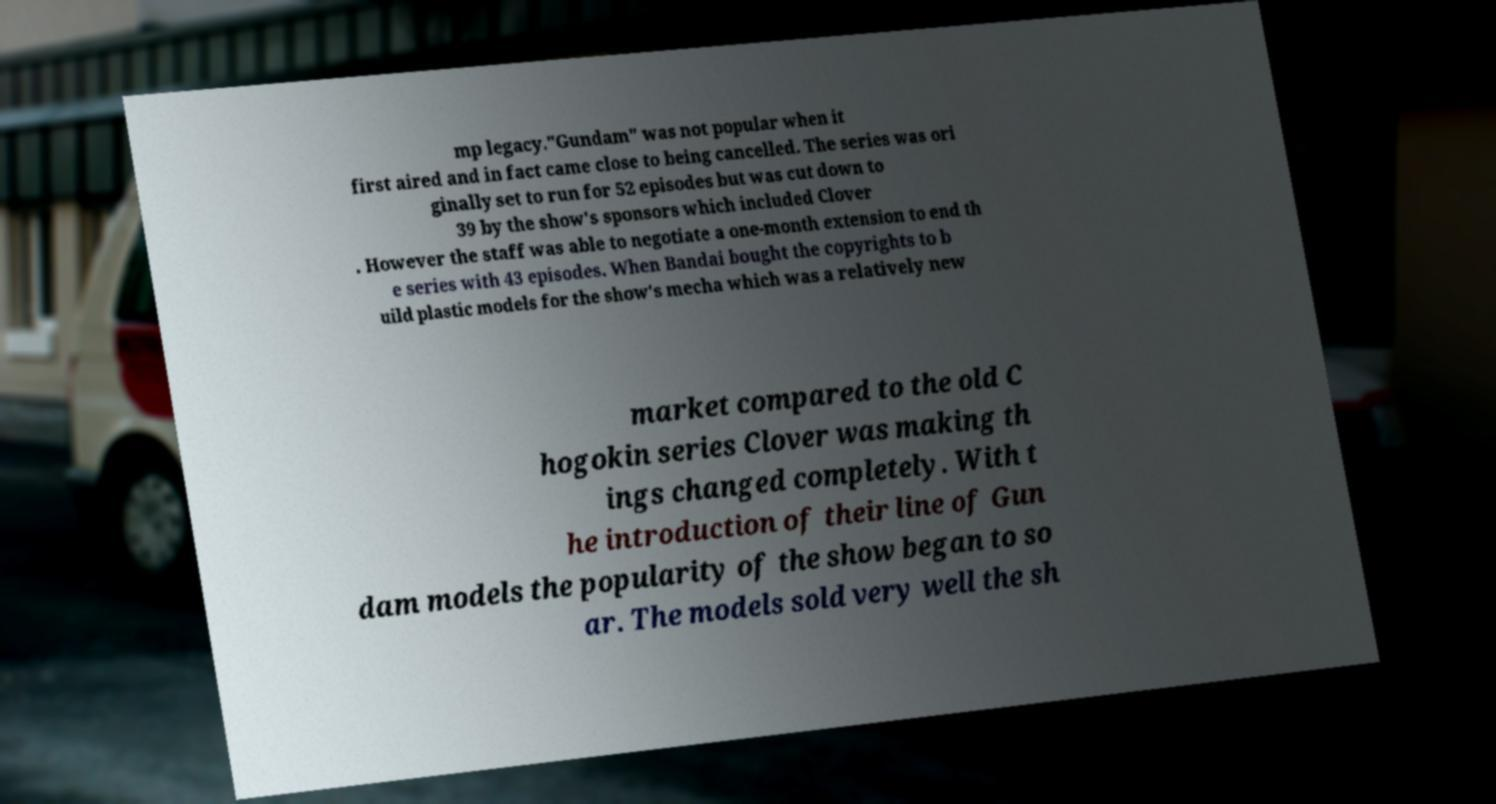Please identify and transcribe the text found in this image. mp legacy."Gundam" was not popular when it first aired and in fact came close to being cancelled. The series was ori ginally set to run for 52 episodes but was cut down to 39 by the show's sponsors which included Clover . However the staff was able to negotiate a one-month extension to end th e series with 43 episodes. When Bandai bought the copyrights to b uild plastic models for the show's mecha which was a relatively new market compared to the old C hogokin series Clover was making th ings changed completely. With t he introduction of their line of Gun dam models the popularity of the show began to so ar. The models sold very well the sh 